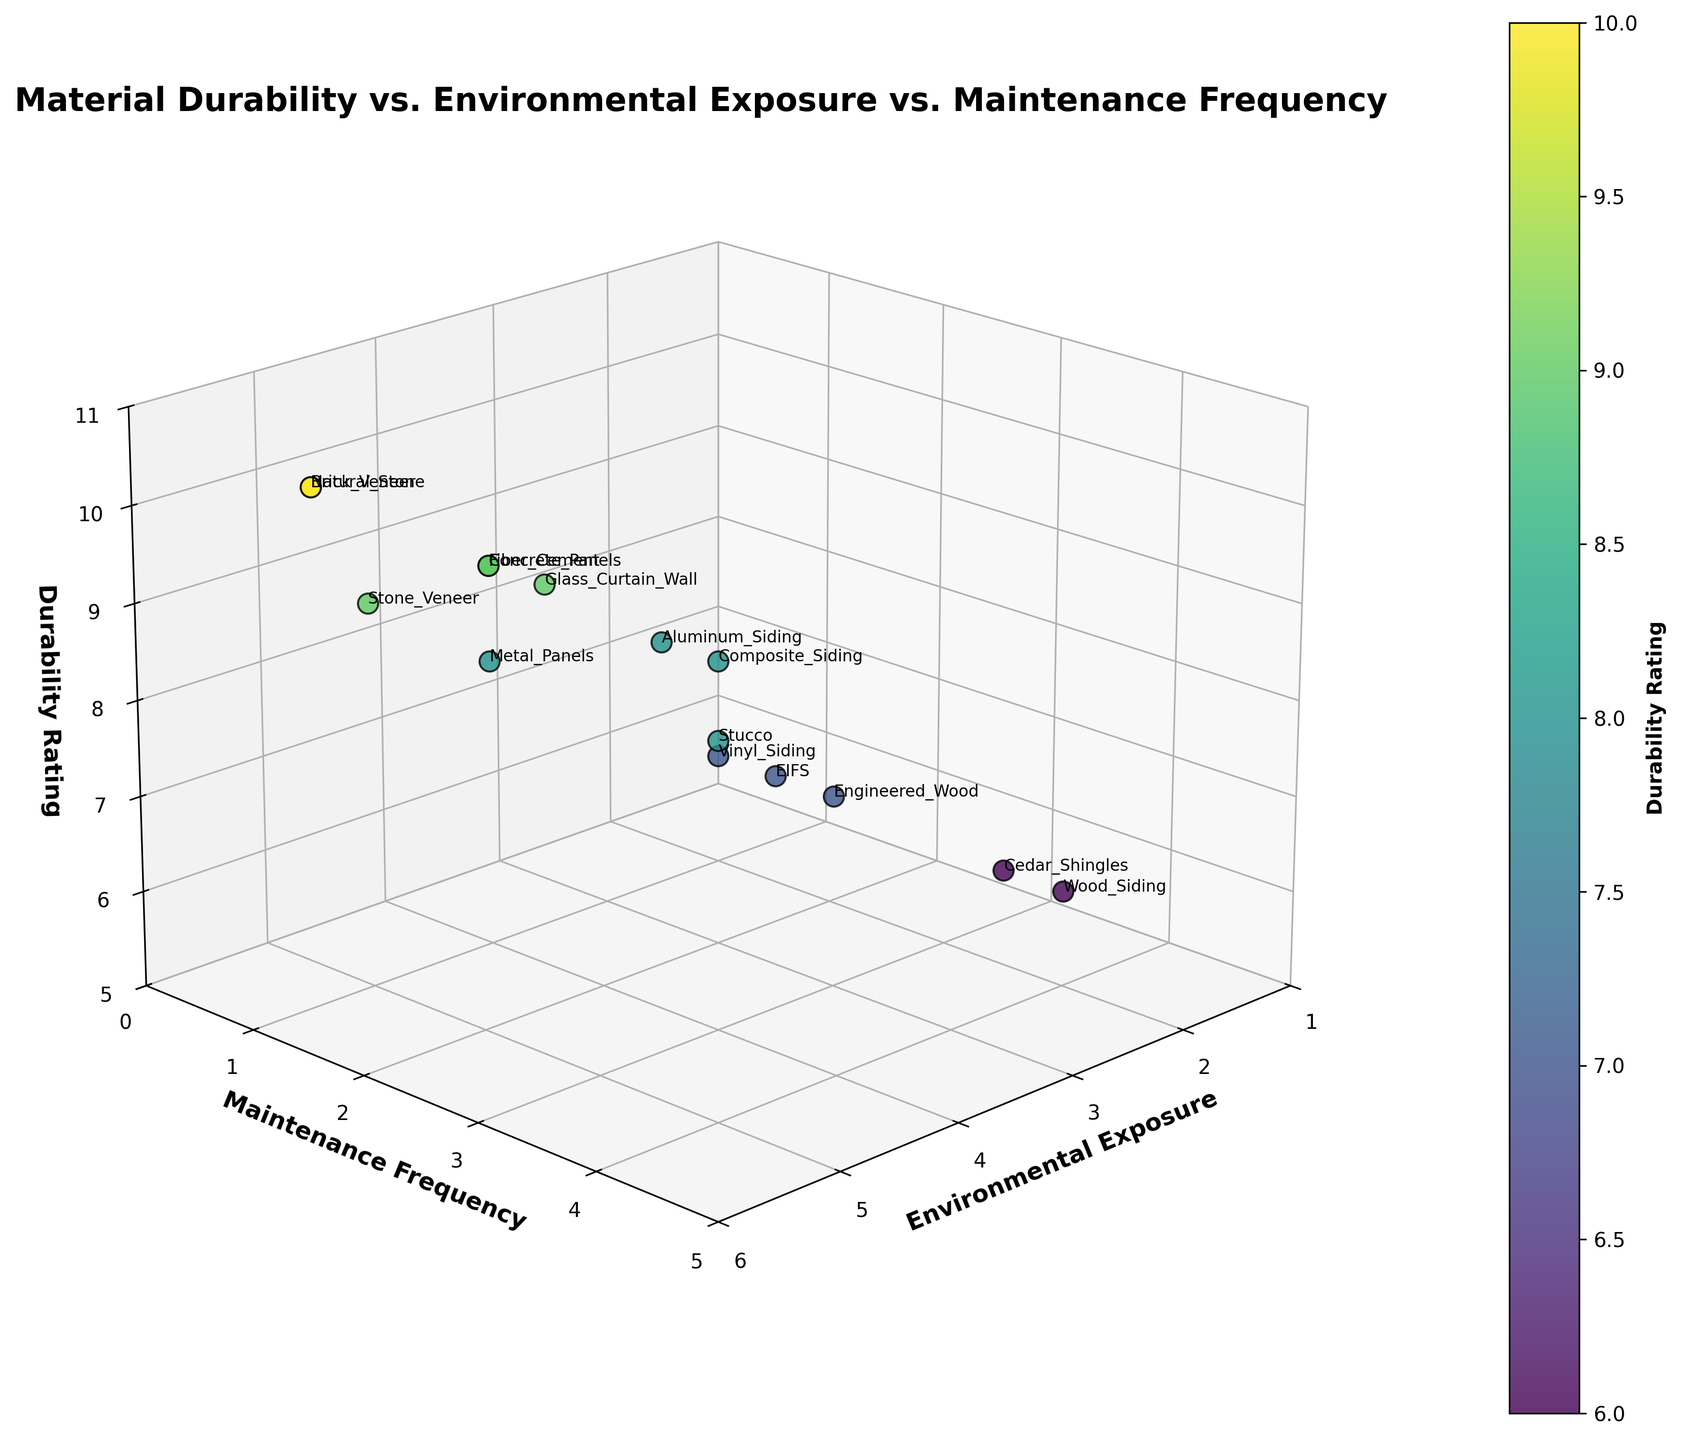What's the title of the figure? The title of the figure is displayed at the top and is labeled in large, bold font.
Answer: Material Durability vs. Environmental Exposure vs. Maintenance Frequency How many different materials are plotted in the figure? There are data points for each unique material, with labels visible next to each point. Counting them reveals the total number of materials listed.
Answer: 15 Which material has the highest durability rating? The highest durability rating is on the z-axis, and by looking at the topmost point, you can see the corresponding material label.
Answer: Brick Veneer and Natural Stone What is the environmental exposure level for Fiber Cement? Locate Fiber Cement in the plot, then look at its position along the x-axis, which represents environmental exposure.
Answer: 4 Which material has the highest maintenance frequency among those with a durability rating of 8? Find all data points with a durability rating of 8 (z=8), then identify which of these points has the highest value along the y-axis for maintenance frequency.
Answer: Stucco What material corresponds to the point at (Environmental Exposure, Maintenance Frequency, Durability Rating) = (2, 4, 6)? Find the point with coordinates (2, 4, 6) in the plot; the label next to this point indicates the material.
Answer: Wood Siding Which materials have a durability rating of 9 and what are their maintenance frequencies? Find all points where the durability rating (z-axis) is 9, then list the corresponding maintenance frequencies (y-axis) for these points.
Answer: Fiber Cement (1), Stone Veneer (1), Concrete Panels (1), Glass Curtain Wall (1.5) What is the average environmental exposure level for materials with a maintenance frequency of 1.5? Identify the points where the maintenance frequency (y-axis) is 1.5, and then calculate the average of their environmental exposure levels (x-axis). The materials corresponding to 1.5 frequency are Aluminum Siding and Glass Curtain Wall. The environmental exposure levels for these are 3 and 4 respectively.
Answer: (3 + 4) / 2 = 3.5 Which material has the lowest maintenance frequency with an environmental exposure of 5? Among the points with an x-axis value of 5, identify the one with the lowest y-axis value which represents maintenance frequency. The materials at x=5 are Brick Veneer, Natural Stone, and Stone Veneer, with maintenance frequencies of 0.5, respectively.
Answer: Brick Veneer and Natural Stone What is the range of durability ratings for materials with environmental exposure levels of 3 or less? Identify all the points where the environmental exposure (x-axis) is 3 or less, then find the minimum and maximum durability ratings (z-axis) among these points. The materials are Vinyl Siding, Wood Siding, Aluminum Siding, EIFS, Engineered Wood, Cedar Shingles, and Composite Siding with durability ratings 7, 6, 8, 7, 7, 6, and 8 respectively.
Answer: 6 to 8 